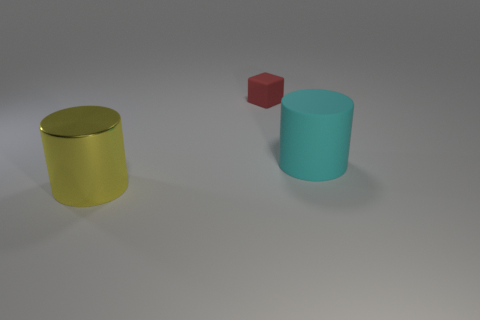Add 2 shiny objects. How many objects exist? 5 Subtract all cylinders. How many objects are left? 1 Add 1 big yellow matte balls. How many big yellow matte balls exist? 1 Subtract 0 gray cylinders. How many objects are left? 3 Subtract all yellow shiny cylinders. Subtract all large cyan rubber things. How many objects are left? 1 Add 3 yellow metallic cylinders. How many yellow metallic cylinders are left? 4 